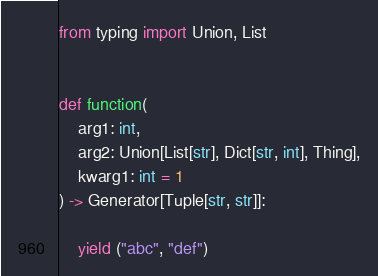Convert code to text. <code><loc_0><loc_0><loc_500><loc_500><_Python_>from typing import Union, List


def function(
    arg1: int,
    arg2: Union[List[str], Dict[str, int], Thing],
    kwarg1: int = 1
) -> Generator[Tuple[str, str]]:

    yield ("abc", "def")
</code> 